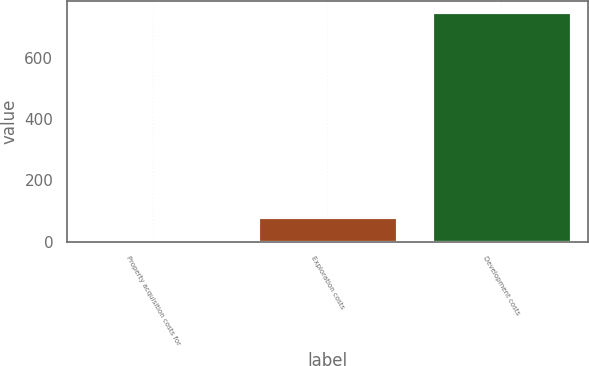<chart> <loc_0><loc_0><loc_500><loc_500><bar_chart><fcel>Property acquisition costs for<fcel>Exploration costs<fcel>Development costs<nl><fcel>7<fcel>81.2<fcel>749<nl></chart> 